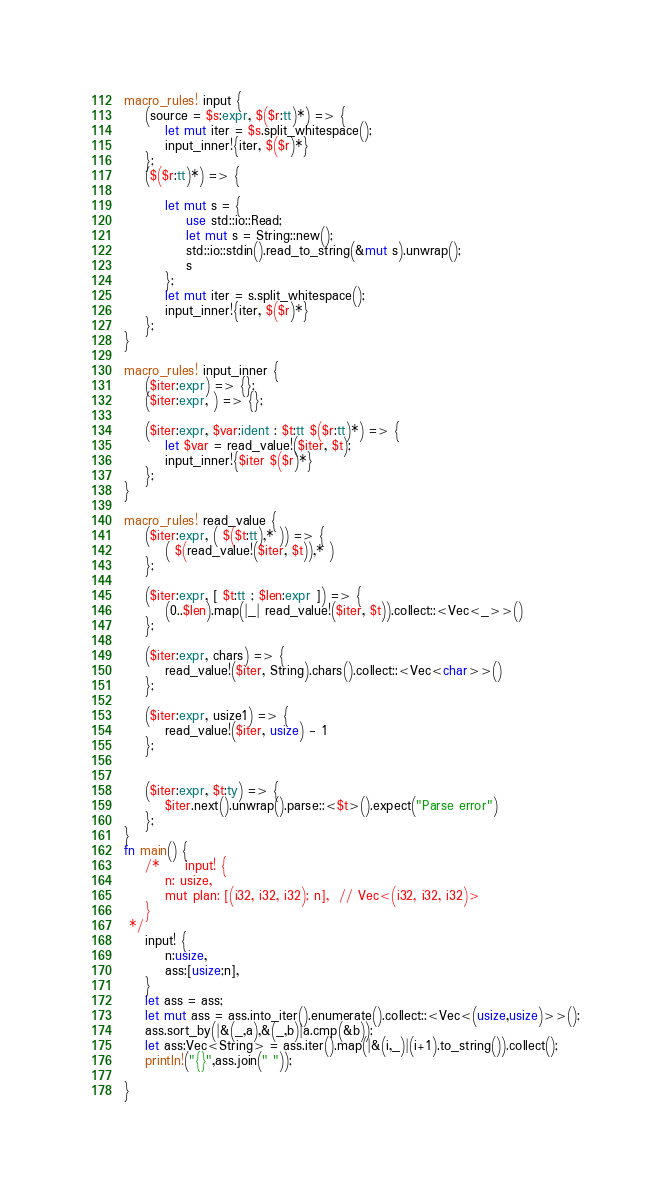Convert code to text. <code><loc_0><loc_0><loc_500><loc_500><_Rust_>
macro_rules! input {
    (source = $s:expr, $($r:tt)*) => {
        let mut iter = $s.split_whitespace();
        input_inner!{iter, $($r)*}
    };
    ($($r:tt)*) => {
 
        let mut s = {
            use std::io::Read;
            let mut s = String::new();
            std::io::stdin().read_to_string(&mut s).unwrap();
            s
        };
        let mut iter = s.split_whitespace();
        input_inner!{iter, $($r)*}
    };
}
 
macro_rules! input_inner {
    ($iter:expr) => {};
    ($iter:expr, ) => {};
 
    ($iter:expr, $var:ident : $t:tt $($r:tt)*) => {
        let $var = read_value!($iter, $t);
        input_inner!{$iter $($r)*}
    };
}
 
macro_rules! read_value {
    ($iter:expr, ( $($t:tt),* )) => {
        ( $(read_value!($iter, $t)),* )
    };
 
    ($iter:expr, [ $t:tt ; $len:expr ]) => {
        (0..$len).map(|_| read_value!($iter, $t)).collect::<Vec<_>>()
    };
 
    ($iter:expr, chars) => {
        read_value!($iter, String).chars().collect::<Vec<char>>()
    };
 
    ($iter:expr, usize1) => {
        read_value!($iter, usize) - 1
    };
 
 
    ($iter:expr, $t:ty) => {
        $iter.next().unwrap().parse::<$t>().expect("Parse error")
    };
}
fn main() {
    /*     input! {
        n: usize,
        mut plan: [(i32, i32, i32); n],  // Vec<(i32, i32, i32)>
    }
 */
    input! {
        n:usize,
        ass:[usize;n],
    }
    let ass = ass;
    let mut ass = ass.into_iter().enumerate().collect::<Vec<(usize,usize)>>();
    ass.sort_by(|&(_,a),&(_,b)|a.cmp(&b));
    let ass:Vec<String> = ass.iter().map(|&(i,_)|(i+1).to_string()).collect();
    println!("{}",ass.join(" "));

}    
</code> 